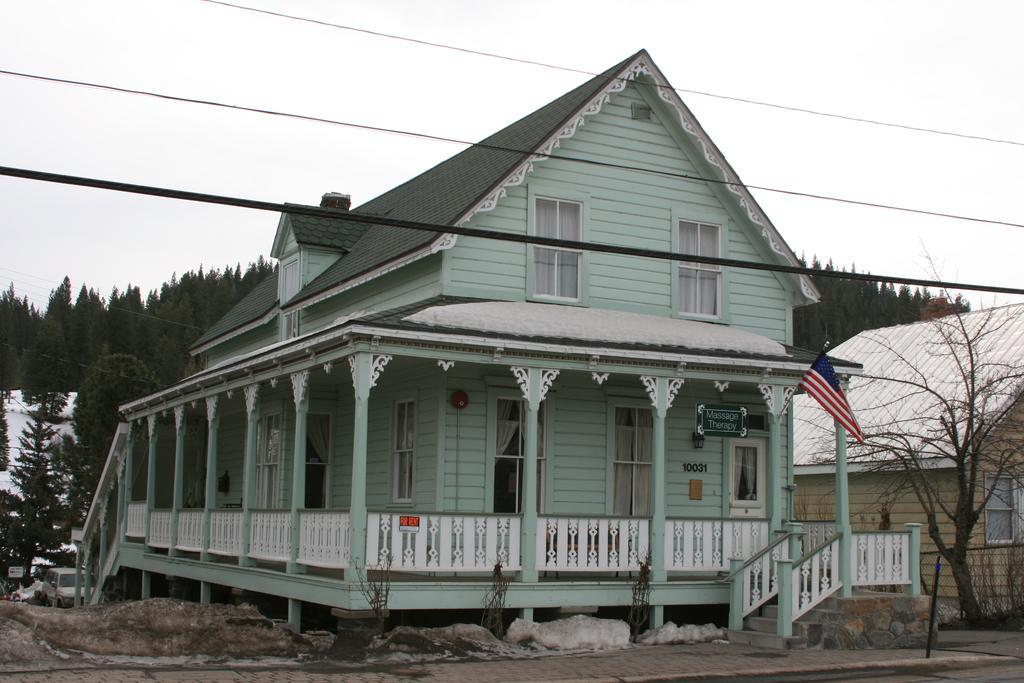Describe this image in one or two sentences. In this image we can see houses, windows, curtains, doors, flag, board, trees, poles and roofs. In the background there is a building, vehicles, trees, electric wires and sky. 